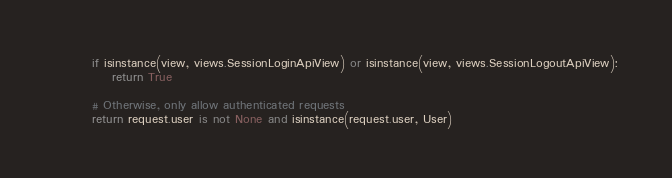Convert code to text. <code><loc_0><loc_0><loc_500><loc_500><_Python_>        if isinstance(view, views.SessionLoginApiView) or isinstance(view, views.SessionLogoutApiView):
            return True

        # Otherwise, only allow authenticated requests
        return request.user is not None and isinstance(request.user, User)
</code> 